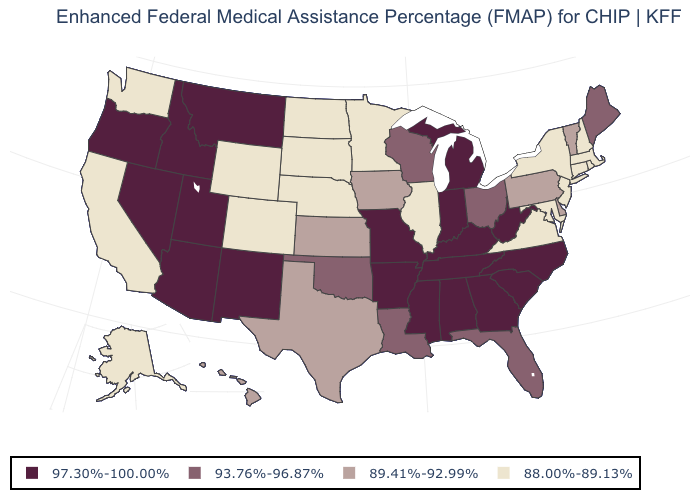Name the states that have a value in the range 88.00%-89.13%?
Concise answer only. Alaska, California, Colorado, Connecticut, Illinois, Maryland, Massachusetts, Minnesota, Nebraska, New Hampshire, New Jersey, New York, North Dakota, Rhode Island, South Dakota, Virginia, Washington, Wyoming. What is the value of Colorado?
Quick response, please. 88.00%-89.13%. Does the first symbol in the legend represent the smallest category?
Short answer required. No. Does New Jersey have the same value as Hawaii?
Concise answer only. No. Name the states that have a value in the range 97.30%-100.00%?
Short answer required. Alabama, Arizona, Arkansas, Georgia, Idaho, Indiana, Kentucky, Michigan, Mississippi, Missouri, Montana, Nevada, New Mexico, North Carolina, Oregon, South Carolina, Tennessee, Utah, West Virginia. What is the value of Delaware?
Short answer required. 89.41%-92.99%. What is the highest value in the Northeast ?
Quick response, please. 93.76%-96.87%. Name the states that have a value in the range 93.76%-96.87%?
Keep it brief. Florida, Louisiana, Maine, Ohio, Oklahoma, Wisconsin. Is the legend a continuous bar?
Answer briefly. No. What is the value of Connecticut?
Give a very brief answer. 88.00%-89.13%. Which states hav the highest value in the South?
Concise answer only. Alabama, Arkansas, Georgia, Kentucky, Mississippi, North Carolina, South Carolina, Tennessee, West Virginia. Which states hav the highest value in the MidWest?
Give a very brief answer. Indiana, Michigan, Missouri. Which states have the highest value in the USA?
Keep it brief. Alabama, Arizona, Arkansas, Georgia, Idaho, Indiana, Kentucky, Michigan, Mississippi, Missouri, Montana, Nevada, New Mexico, North Carolina, Oregon, South Carolina, Tennessee, Utah, West Virginia. Name the states that have a value in the range 97.30%-100.00%?
Give a very brief answer. Alabama, Arizona, Arkansas, Georgia, Idaho, Indiana, Kentucky, Michigan, Mississippi, Missouri, Montana, Nevada, New Mexico, North Carolina, Oregon, South Carolina, Tennessee, Utah, West Virginia. 